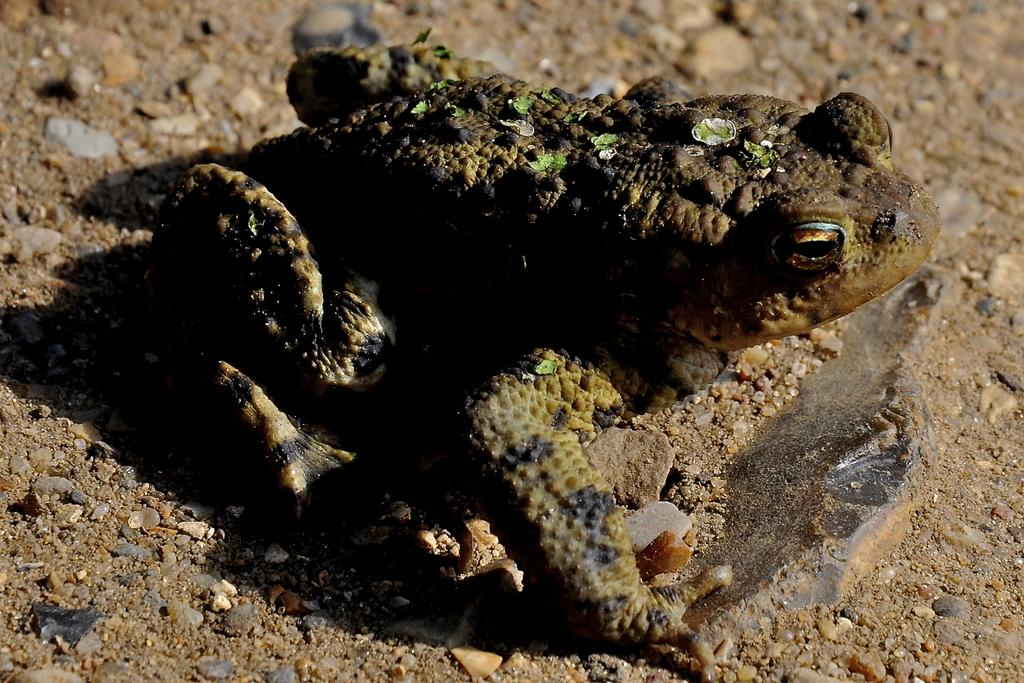What type of animal is in the image? There is a frog in the image. Where is the frog located? The frog is on the land. What other objects can be seen in the image? There are rocks in the image. What type of humor can be found in the image? There is no humor present in the image; it simply features a frog on the land and rocks. 